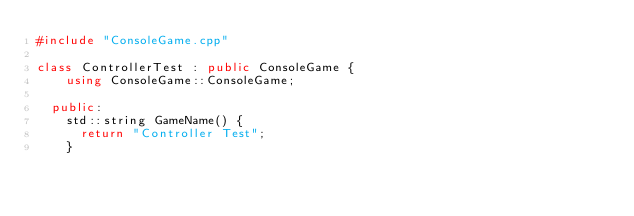<code> <loc_0><loc_0><loc_500><loc_500><_C++_>#include "ConsoleGame.cpp"

class ControllerTest : public ConsoleGame {
    using ConsoleGame::ConsoleGame;

  public:
    std::string GameName() {
      return "Controller Test";
    }</code> 